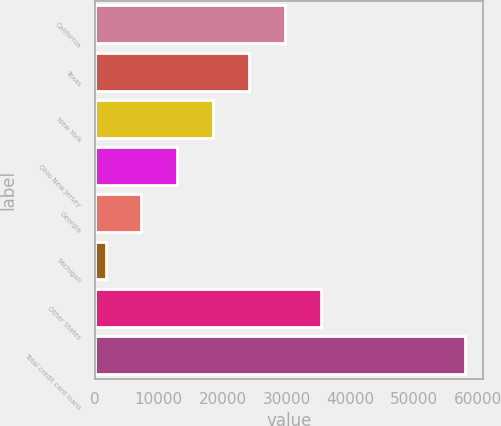Convert chart. <chart><loc_0><loc_0><loc_500><loc_500><bar_chart><fcel>California<fcel>Texas<fcel>New York<fcel>Ohio New Jersey<fcel>Georgia<fcel>Michigan<fcel>Other States<fcel>Total credit card loans<nl><fcel>29778.5<fcel>24155<fcel>18531.5<fcel>12908<fcel>7284.5<fcel>1661<fcel>35402<fcel>57896<nl></chart> 